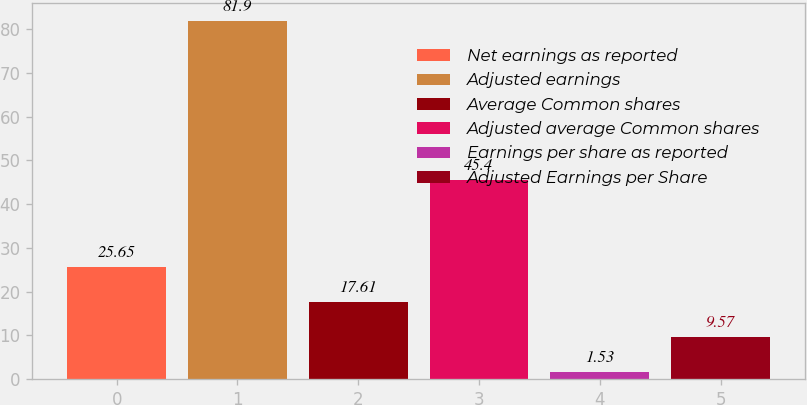<chart> <loc_0><loc_0><loc_500><loc_500><bar_chart><fcel>Net earnings as reported<fcel>Adjusted earnings<fcel>Average Common shares<fcel>Adjusted average Common shares<fcel>Earnings per share as reported<fcel>Adjusted Earnings per Share<nl><fcel>25.65<fcel>81.9<fcel>17.61<fcel>45.4<fcel>1.53<fcel>9.57<nl></chart> 